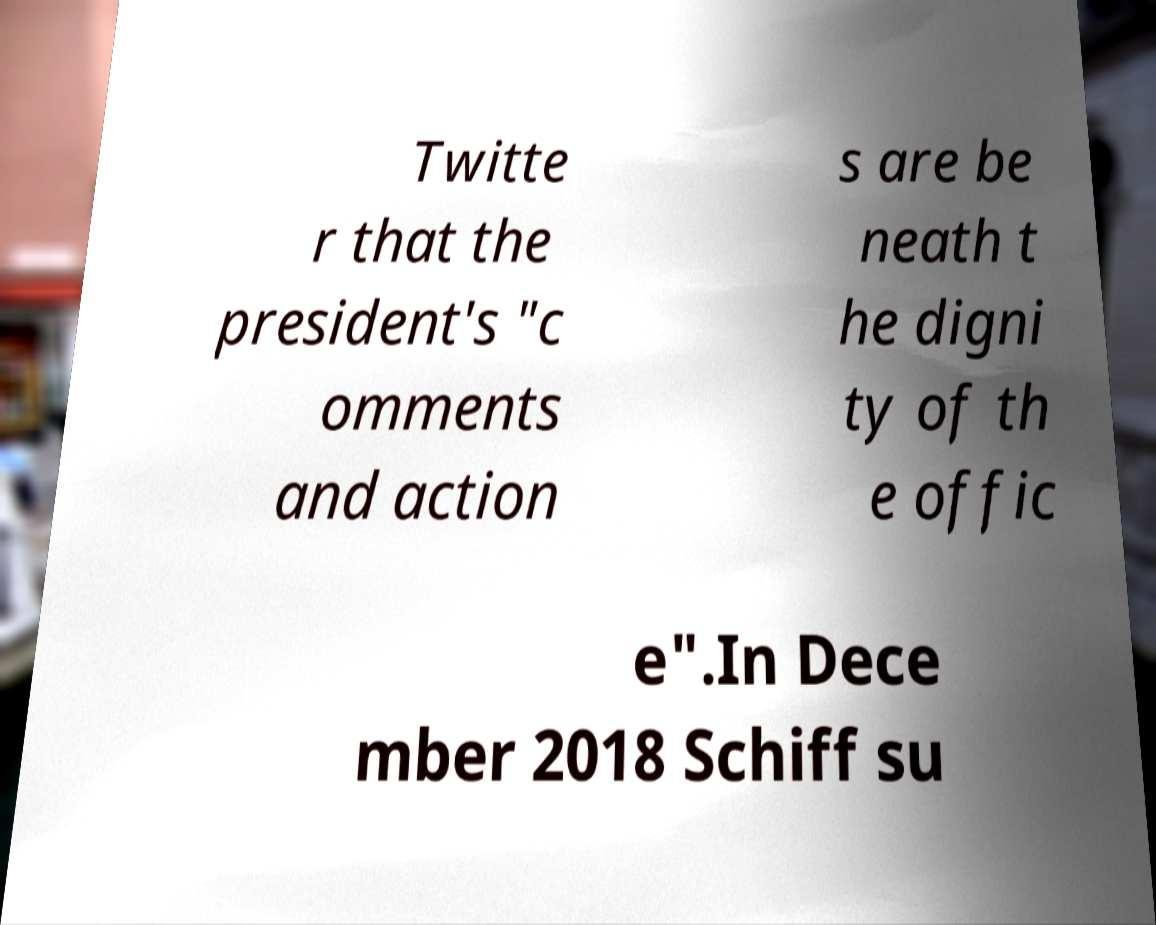Could you extract and type out the text from this image? Twitte r that the president's "c omments and action s are be neath t he digni ty of th e offic e".In Dece mber 2018 Schiff su 